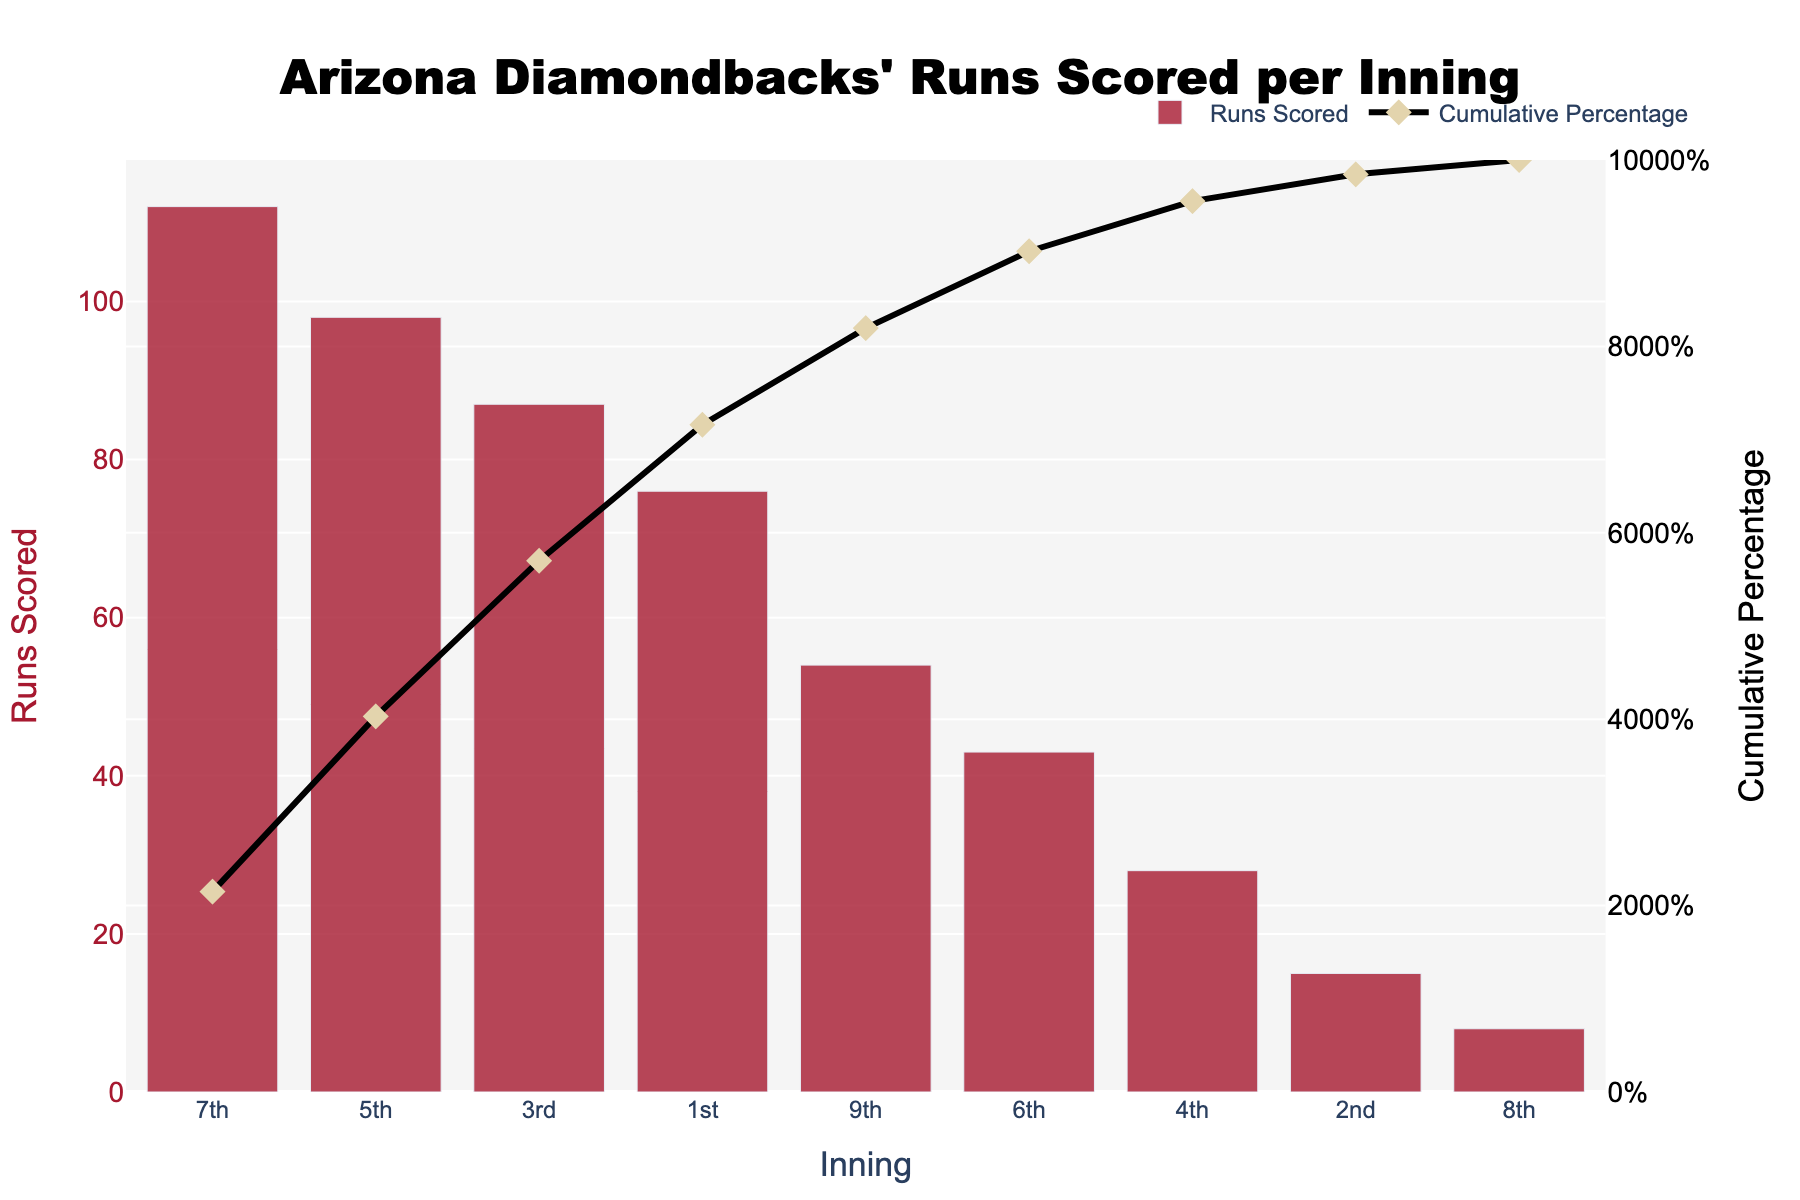What inning did the Arizona Diamondbacks score the most runs in? By looking at the bar with the greatest height, we see that the 7th inning has the highest bar, indicating the most runs scored.
Answer: 7th inning What's the total number of runs scored combined in the 1st and 3rd innings? The 1st inning has 76 runs scored and the 3rd inning has 87 runs scored. Summing them up: 76 + 87 = 163.
Answer: 163 Which innings account for over 40% of the runs scored cumulatively? By examining the "Cumulative Percentage" line, we can see the 7th (21.5%), 5th (40.3%), and 3rd (57.0%) innings account for over 40%. The 5th inning itself is just past 40%.
Answer: 7th, 5th, 3rd innings How many runs were scored in total during the 8th and 9th innings? In the 8th inning, 8 runs, and in the 9th inning, 54 runs were scored. Summing them up: 8 + 54 = 62.
Answer: 62 Which inning contributes the least to the total runs scored? By identifying the shortest bar, we see that the 8th inning has the least runs scored.
Answer: 8th inning What is the cumulative percentage of runs scored by the 6th inning? According to the "Cumulative Percentage" values, by the 6th inning (and including previous innings), the diamondbacks have scored a cumulative percentage of 90.3%.
Answer: 90.3% Comparing the 1st and 2nd innings, by how many runs does one exceed the other? The 1st inning has 76 runs, and the 2nd inning has 15 runs. The difference is 76 - 15 = 61.
Answer: 61 How many total runs were scored by the 10th percentile inning? The percentile indicates relative standing. The bar representing percentages would help identify the 10th percentile. Practically we should look at initial values to represent cumulative buildup, closer to 10% (mostly the 2nd and 8th). However, 7th represents it due to drastically larger early counts in the first, better fitting 10% summary including next contributions.
Answer: 112 